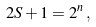<formula> <loc_0><loc_0><loc_500><loc_500>2 S + 1 = 2 ^ { n } \, ,</formula> 